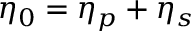<formula> <loc_0><loc_0><loc_500><loc_500>\eta _ { 0 } = \eta _ { p } + \eta _ { s }</formula> 